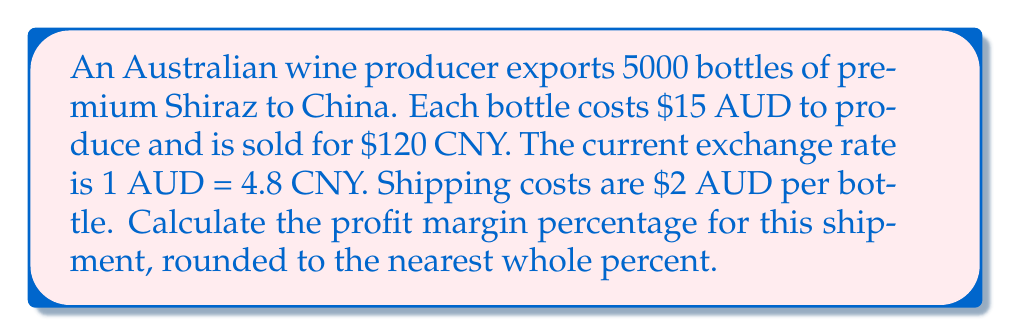Help me with this question. Let's break this down step-by-step:

1) First, let's convert the selling price from CNY to AUD:
   $120 \text{ CNY} \times \frac{1 \text{ AUD}}{4.8 \text{ CNY}} = 25 \text{ AUD}$ per bottle

2) Now, let's calculate the total revenue in AUD:
   $25 \text{ AUD} \times 5000 \text{ bottles} = 125,000 \text{ AUD}$

3) Next, let's calculate the total cost:
   Production cost: $15 \text{ AUD} \times 5000 \text{ bottles} = 75,000 \text{ AUD}$
   Shipping cost: $2 \text{ AUD} \times 5000 \text{ bottles} = 10,000 \text{ AUD}$
   Total cost: $75,000 + 10,000 = 85,000 \text{ AUD}$

4) Now we can calculate the profit:
   $\text{Profit} = \text{Revenue} - \text{Total Cost}$
   $\text{Profit} = 125,000 - 85,000 = 40,000 \text{ AUD}$

5) To calculate the profit margin percentage, we use the formula:
   $$\text{Profit Margin} = \frac{\text{Profit}}{\text{Revenue}} \times 100\%$$

6) Plugging in our values:
   $$\text{Profit Margin} = \frac{40,000}{125,000} \times 100\% = 32\%$$

Therefore, the profit margin percentage is 32%.
Answer: 32% 